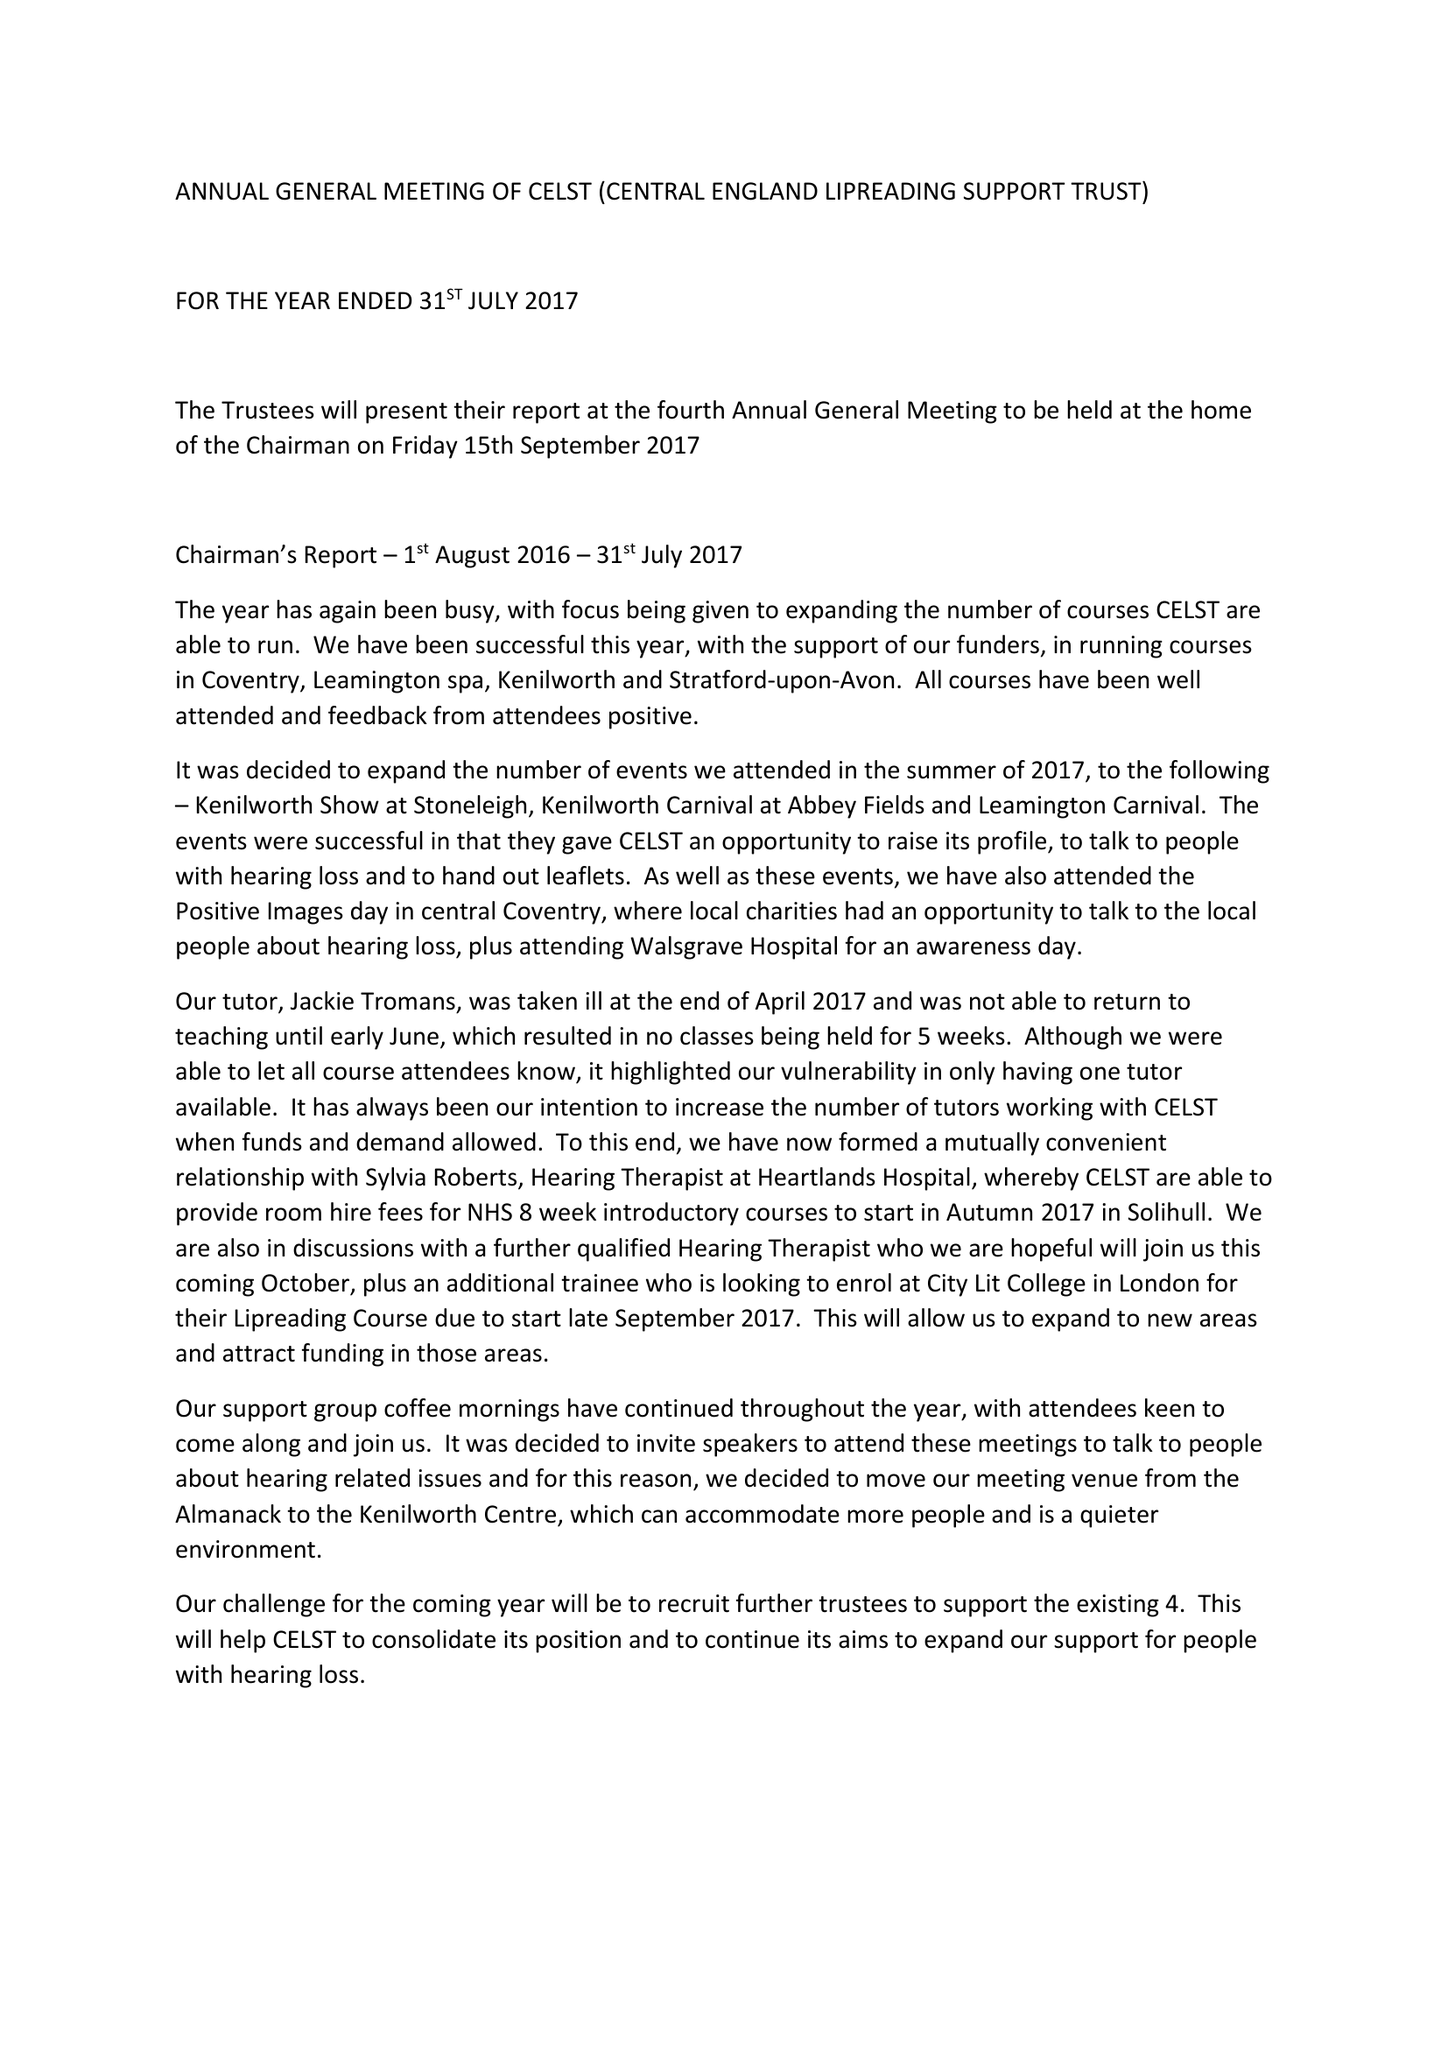What is the value for the spending_annually_in_british_pounds?
Answer the question using a single word or phrase. 9879.00 